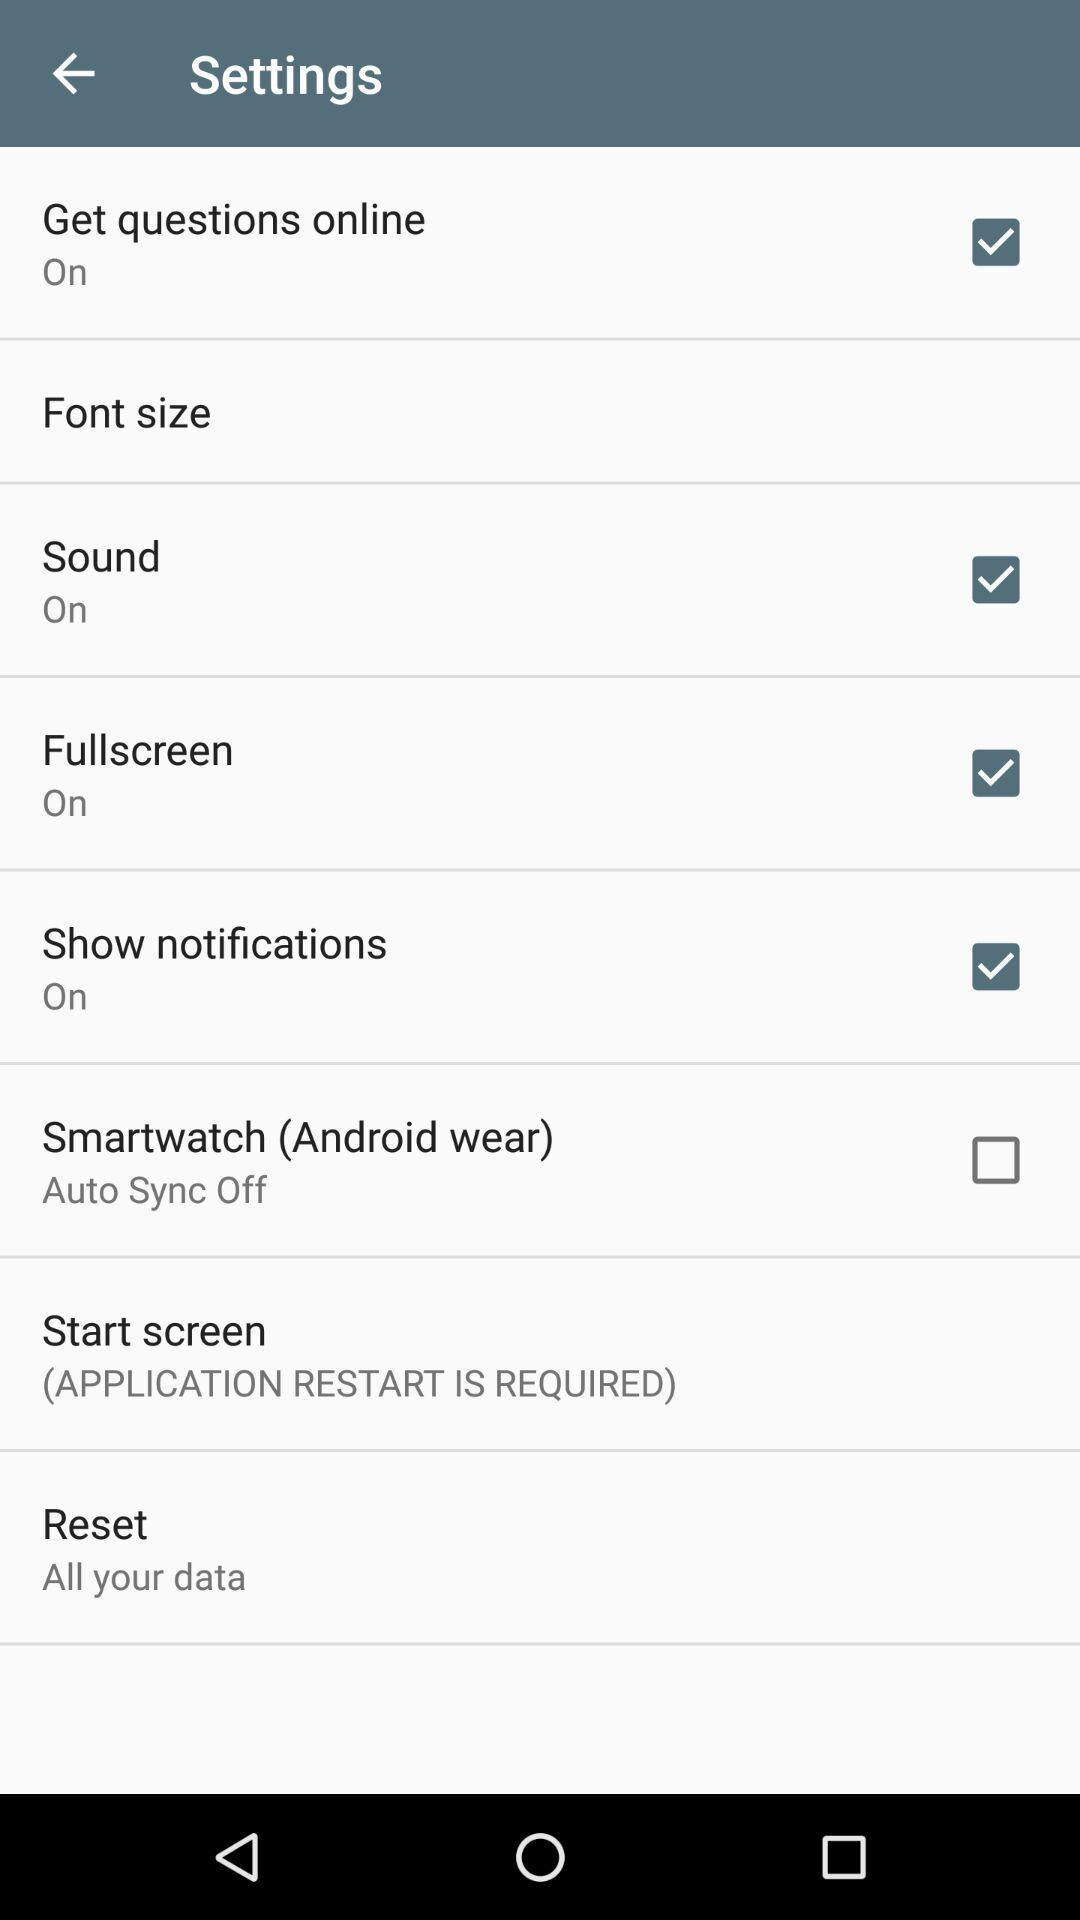How many items are in the settings menu?
Answer the question using a single word or phrase. 8 